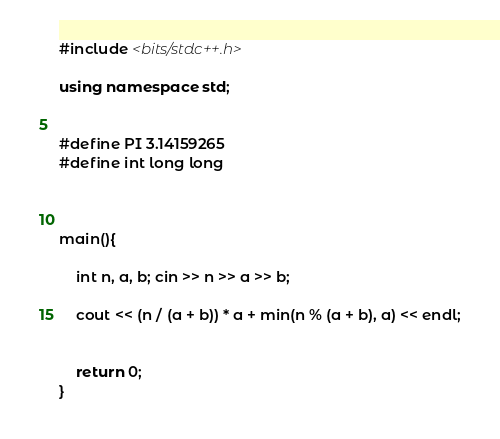Convert code to text. <code><loc_0><loc_0><loc_500><loc_500><_C++_>#include <bits/stdc++.h>

using namespace std;


#define PI 3.14159265
#define int long long



main(){

	int n, a, b; cin >> n >> a >> b;

	cout << (n / (a + b)) * a + min(n % (a + b), a) << endl;
	
	
	return 0;
}</code> 